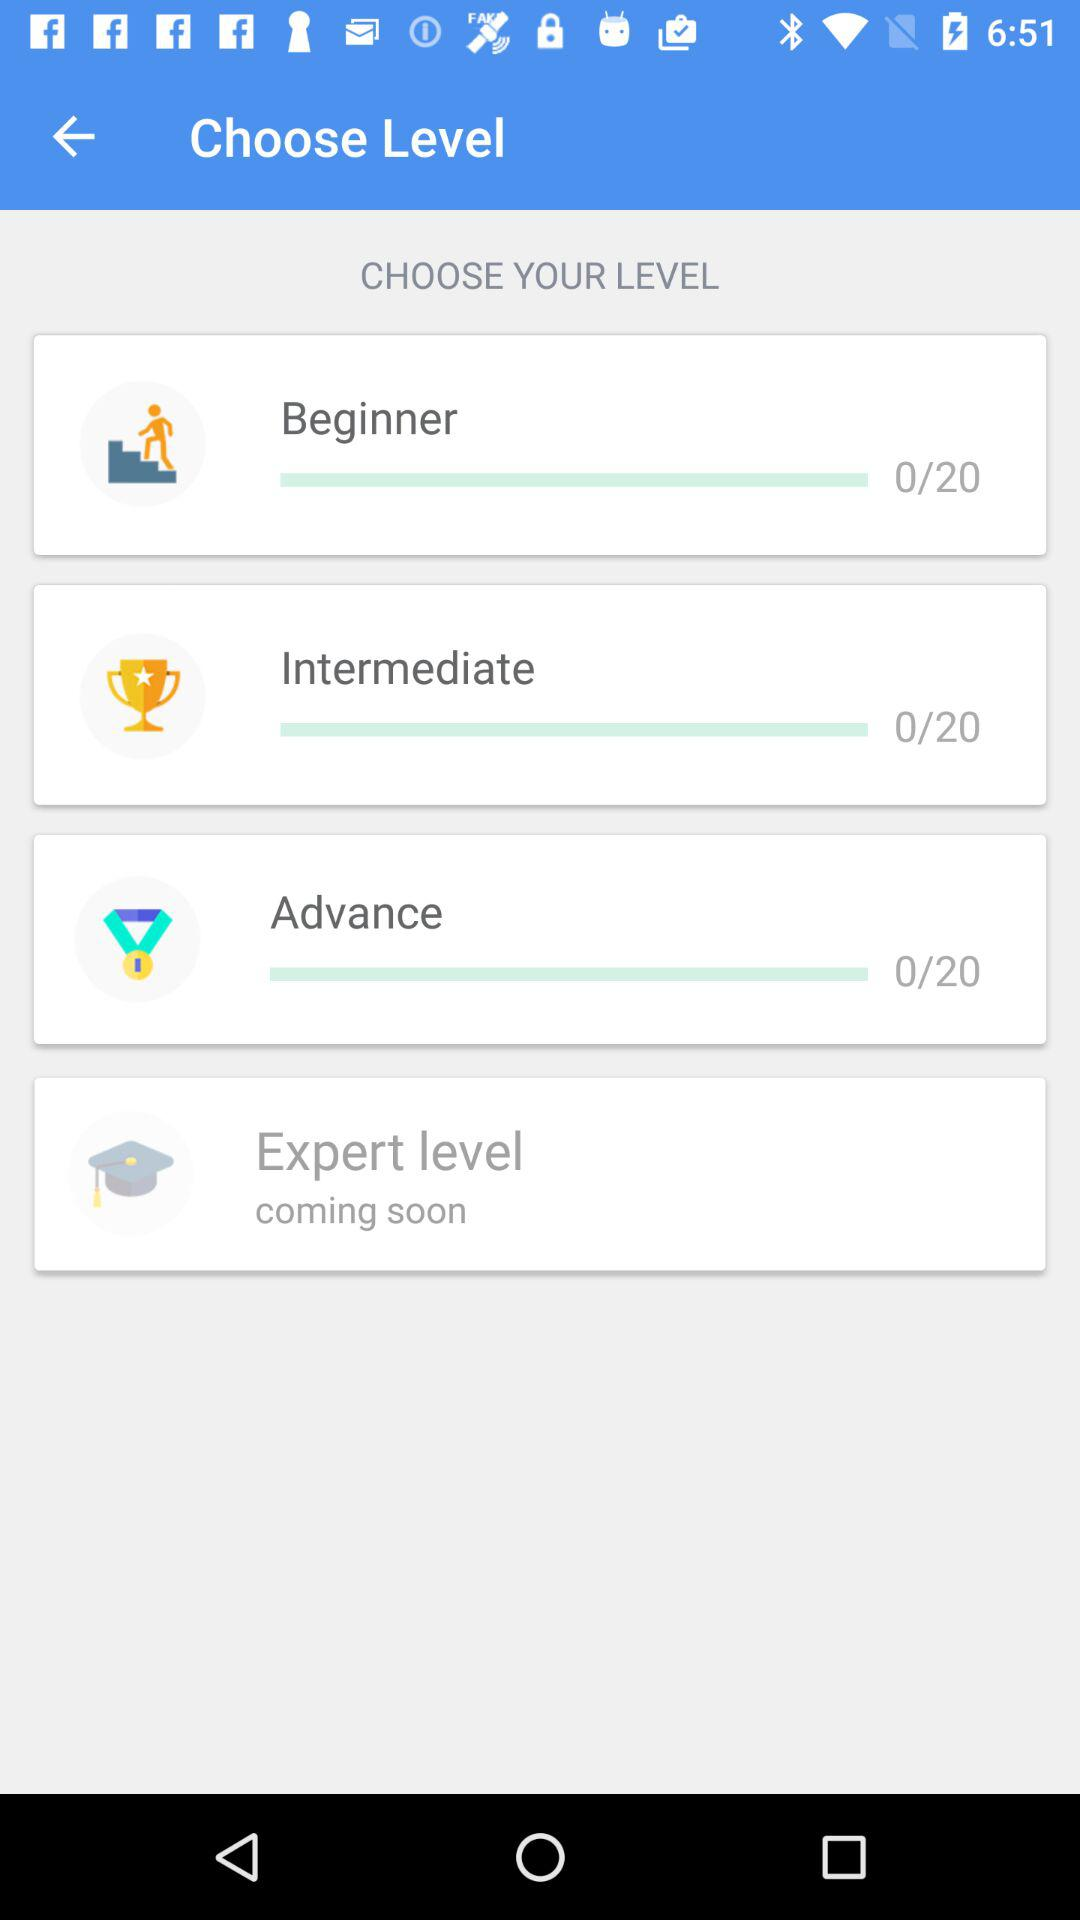Which tab is selected? The selected tab is "LEARN". 